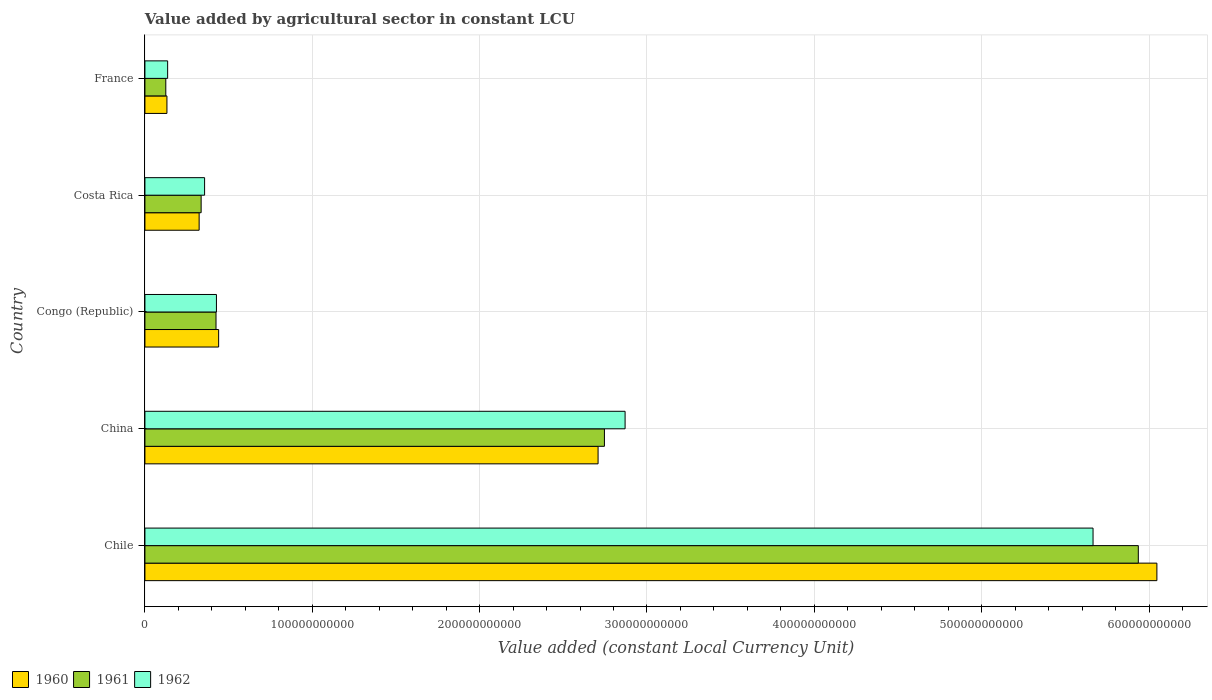How many groups of bars are there?
Your answer should be compact. 5. Are the number of bars on each tick of the Y-axis equal?
Make the answer very short. Yes. How many bars are there on the 4th tick from the top?
Your answer should be compact. 3. How many bars are there on the 1st tick from the bottom?
Keep it short and to the point. 3. What is the value added by agricultural sector in 1962 in France?
Ensure brevity in your answer.  1.36e+1. Across all countries, what is the maximum value added by agricultural sector in 1961?
Your answer should be compact. 5.94e+11. Across all countries, what is the minimum value added by agricultural sector in 1961?
Your answer should be very brief. 1.25e+1. In which country was the value added by agricultural sector in 1961 maximum?
Give a very brief answer. Chile. In which country was the value added by agricultural sector in 1962 minimum?
Give a very brief answer. France. What is the total value added by agricultural sector in 1960 in the graph?
Ensure brevity in your answer.  9.65e+11. What is the difference between the value added by agricultural sector in 1960 in Costa Rica and that in France?
Provide a short and direct response. 1.92e+1. What is the difference between the value added by agricultural sector in 1962 in Chile and the value added by agricultural sector in 1961 in France?
Provide a short and direct response. 5.54e+11. What is the average value added by agricultural sector in 1961 per country?
Provide a short and direct response. 1.91e+11. What is the difference between the value added by agricultural sector in 1961 and value added by agricultural sector in 1962 in Chile?
Make the answer very short. 2.70e+1. What is the ratio of the value added by agricultural sector in 1962 in China to that in Costa Rica?
Ensure brevity in your answer.  8.05. Is the difference between the value added by agricultural sector in 1961 in Chile and Congo (Republic) greater than the difference between the value added by agricultural sector in 1962 in Chile and Congo (Republic)?
Provide a succinct answer. Yes. What is the difference between the highest and the second highest value added by agricultural sector in 1960?
Your response must be concise. 3.34e+11. What is the difference between the highest and the lowest value added by agricultural sector in 1961?
Offer a terse response. 5.81e+11. In how many countries, is the value added by agricultural sector in 1960 greater than the average value added by agricultural sector in 1960 taken over all countries?
Offer a terse response. 2. What does the 1st bar from the top in Congo (Republic) represents?
Offer a very short reply. 1962. What does the 2nd bar from the bottom in China represents?
Your answer should be very brief. 1961. How many bars are there?
Give a very brief answer. 15. How many countries are there in the graph?
Keep it short and to the point. 5. What is the difference between two consecutive major ticks on the X-axis?
Your answer should be very brief. 1.00e+11. Does the graph contain any zero values?
Provide a short and direct response. No. How are the legend labels stacked?
Keep it short and to the point. Horizontal. What is the title of the graph?
Your answer should be compact. Value added by agricultural sector in constant LCU. Does "2005" appear as one of the legend labels in the graph?
Keep it short and to the point. No. What is the label or title of the X-axis?
Provide a short and direct response. Value added (constant Local Currency Unit). What is the Value added (constant Local Currency Unit) in 1960 in Chile?
Provide a short and direct response. 6.05e+11. What is the Value added (constant Local Currency Unit) in 1961 in Chile?
Ensure brevity in your answer.  5.94e+11. What is the Value added (constant Local Currency Unit) of 1962 in Chile?
Your answer should be very brief. 5.67e+11. What is the Value added (constant Local Currency Unit) of 1960 in China?
Provide a short and direct response. 2.71e+11. What is the Value added (constant Local Currency Unit) in 1961 in China?
Provide a short and direct response. 2.75e+11. What is the Value added (constant Local Currency Unit) of 1962 in China?
Make the answer very short. 2.87e+11. What is the Value added (constant Local Currency Unit) in 1960 in Congo (Republic)?
Keep it short and to the point. 4.41e+1. What is the Value added (constant Local Currency Unit) in 1961 in Congo (Republic)?
Provide a short and direct response. 4.25e+1. What is the Value added (constant Local Currency Unit) of 1962 in Congo (Republic)?
Make the answer very short. 4.27e+1. What is the Value added (constant Local Currency Unit) of 1960 in Costa Rica?
Your answer should be compact. 3.24e+1. What is the Value added (constant Local Currency Unit) in 1961 in Costa Rica?
Ensure brevity in your answer.  3.36e+1. What is the Value added (constant Local Currency Unit) in 1962 in Costa Rica?
Offer a very short reply. 3.57e+1. What is the Value added (constant Local Currency Unit) in 1960 in France?
Offer a very short reply. 1.32e+1. What is the Value added (constant Local Currency Unit) in 1961 in France?
Ensure brevity in your answer.  1.25e+1. What is the Value added (constant Local Currency Unit) in 1962 in France?
Give a very brief answer. 1.36e+1. Across all countries, what is the maximum Value added (constant Local Currency Unit) of 1960?
Offer a terse response. 6.05e+11. Across all countries, what is the maximum Value added (constant Local Currency Unit) of 1961?
Keep it short and to the point. 5.94e+11. Across all countries, what is the maximum Value added (constant Local Currency Unit) in 1962?
Offer a very short reply. 5.67e+11. Across all countries, what is the minimum Value added (constant Local Currency Unit) in 1960?
Give a very brief answer. 1.32e+1. Across all countries, what is the minimum Value added (constant Local Currency Unit) in 1961?
Offer a very short reply. 1.25e+1. Across all countries, what is the minimum Value added (constant Local Currency Unit) in 1962?
Your answer should be compact. 1.36e+1. What is the total Value added (constant Local Currency Unit) of 1960 in the graph?
Ensure brevity in your answer.  9.65e+11. What is the total Value added (constant Local Currency Unit) of 1961 in the graph?
Keep it short and to the point. 9.57e+11. What is the total Value added (constant Local Currency Unit) of 1962 in the graph?
Your answer should be compact. 9.45e+11. What is the difference between the Value added (constant Local Currency Unit) in 1960 in Chile and that in China?
Make the answer very short. 3.34e+11. What is the difference between the Value added (constant Local Currency Unit) in 1961 in Chile and that in China?
Offer a very short reply. 3.19e+11. What is the difference between the Value added (constant Local Currency Unit) in 1962 in Chile and that in China?
Make the answer very short. 2.80e+11. What is the difference between the Value added (constant Local Currency Unit) in 1960 in Chile and that in Congo (Republic)?
Ensure brevity in your answer.  5.61e+11. What is the difference between the Value added (constant Local Currency Unit) of 1961 in Chile and that in Congo (Republic)?
Make the answer very short. 5.51e+11. What is the difference between the Value added (constant Local Currency Unit) of 1962 in Chile and that in Congo (Republic)?
Keep it short and to the point. 5.24e+11. What is the difference between the Value added (constant Local Currency Unit) of 1960 in Chile and that in Costa Rica?
Make the answer very short. 5.72e+11. What is the difference between the Value added (constant Local Currency Unit) in 1961 in Chile and that in Costa Rica?
Provide a succinct answer. 5.60e+11. What is the difference between the Value added (constant Local Currency Unit) in 1962 in Chile and that in Costa Rica?
Ensure brevity in your answer.  5.31e+11. What is the difference between the Value added (constant Local Currency Unit) in 1960 in Chile and that in France?
Your answer should be very brief. 5.92e+11. What is the difference between the Value added (constant Local Currency Unit) of 1961 in Chile and that in France?
Ensure brevity in your answer.  5.81e+11. What is the difference between the Value added (constant Local Currency Unit) in 1962 in Chile and that in France?
Offer a terse response. 5.53e+11. What is the difference between the Value added (constant Local Currency Unit) in 1960 in China and that in Congo (Republic)?
Provide a short and direct response. 2.27e+11. What is the difference between the Value added (constant Local Currency Unit) of 1961 in China and that in Congo (Republic)?
Your answer should be very brief. 2.32e+11. What is the difference between the Value added (constant Local Currency Unit) of 1962 in China and that in Congo (Republic)?
Offer a terse response. 2.44e+11. What is the difference between the Value added (constant Local Currency Unit) in 1960 in China and that in Costa Rica?
Your response must be concise. 2.38e+11. What is the difference between the Value added (constant Local Currency Unit) of 1961 in China and that in Costa Rica?
Give a very brief answer. 2.41e+11. What is the difference between the Value added (constant Local Currency Unit) in 1962 in China and that in Costa Rica?
Your response must be concise. 2.51e+11. What is the difference between the Value added (constant Local Currency Unit) in 1960 in China and that in France?
Provide a short and direct response. 2.58e+11. What is the difference between the Value added (constant Local Currency Unit) in 1961 in China and that in France?
Keep it short and to the point. 2.62e+11. What is the difference between the Value added (constant Local Currency Unit) of 1962 in China and that in France?
Ensure brevity in your answer.  2.73e+11. What is the difference between the Value added (constant Local Currency Unit) in 1960 in Congo (Republic) and that in Costa Rica?
Make the answer very short. 1.17e+1. What is the difference between the Value added (constant Local Currency Unit) of 1961 in Congo (Republic) and that in Costa Rica?
Offer a very short reply. 8.89e+09. What is the difference between the Value added (constant Local Currency Unit) of 1962 in Congo (Republic) and that in Costa Rica?
Your answer should be compact. 7.08e+09. What is the difference between the Value added (constant Local Currency Unit) of 1960 in Congo (Republic) and that in France?
Keep it short and to the point. 3.09e+1. What is the difference between the Value added (constant Local Currency Unit) in 1961 in Congo (Republic) and that in France?
Offer a very short reply. 3.00e+1. What is the difference between the Value added (constant Local Currency Unit) of 1962 in Congo (Republic) and that in France?
Keep it short and to the point. 2.92e+1. What is the difference between the Value added (constant Local Currency Unit) in 1960 in Costa Rica and that in France?
Offer a terse response. 1.92e+1. What is the difference between the Value added (constant Local Currency Unit) of 1961 in Costa Rica and that in France?
Provide a short and direct response. 2.11e+1. What is the difference between the Value added (constant Local Currency Unit) in 1962 in Costa Rica and that in France?
Ensure brevity in your answer.  2.21e+1. What is the difference between the Value added (constant Local Currency Unit) in 1960 in Chile and the Value added (constant Local Currency Unit) in 1961 in China?
Offer a very short reply. 3.30e+11. What is the difference between the Value added (constant Local Currency Unit) in 1960 in Chile and the Value added (constant Local Currency Unit) in 1962 in China?
Your answer should be compact. 3.18e+11. What is the difference between the Value added (constant Local Currency Unit) of 1961 in Chile and the Value added (constant Local Currency Unit) of 1962 in China?
Ensure brevity in your answer.  3.07e+11. What is the difference between the Value added (constant Local Currency Unit) in 1960 in Chile and the Value added (constant Local Currency Unit) in 1961 in Congo (Republic)?
Provide a short and direct response. 5.62e+11. What is the difference between the Value added (constant Local Currency Unit) of 1960 in Chile and the Value added (constant Local Currency Unit) of 1962 in Congo (Republic)?
Provide a succinct answer. 5.62e+11. What is the difference between the Value added (constant Local Currency Unit) in 1961 in Chile and the Value added (constant Local Currency Unit) in 1962 in Congo (Republic)?
Make the answer very short. 5.51e+11. What is the difference between the Value added (constant Local Currency Unit) of 1960 in Chile and the Value added (constant Local Currency Unit) of 1961 in Costa Rica?
Your response must be concise. 5.71e+11. What is the difference between the Value added (constant Local Currency Unit) of 1960 in Chile and the Value added (constant Local Currency Unit) of 1962 in Costa Rica?
Offer a terse response. 5.69e+11. What is the difference between the Value added (constant Local Currency Unit) in 1961 in Chile and the Value added (constant Local Currency Unit) in 1962 in Costa Rica?
Offer a terse response. 5.58e+11. What is the difference between the Value added (constant Local Currency Unit) of 1960 in Chile and the Value added (constant Local Currency Unit) of 1961 in France?
Give a very brief answer. 5.92e+11. What is the difference between the Value added (constant Local Currency Unit) in 1960 in Chile and the Value added (constant Local Currency Unit) in 1962 in France?
Offer a terse response. 5.91e+11. What is the difference between the Value added (constant Local Currency Unit) in 1961 in Chile and the Value added (constant Local Currency Unit) in 1962 in France?
Offer a very short reply. 5.80e+11. What is the difference between the Value added (constant Local Currency Unit) in 1960 in China and the Value added (constant Local Currency Unit) in 1961 in Congo (Republic)?
Your response must be concise. 2.28e+11. What is the difference between the Value added (constant Local Currency Unit) in 1960 in China and the Value added (constant Local Currency Unit) in 1962 in Congo (Republic)?
Offer a very short reply. 2.28e+11. What is the difference between the Value added (constant Local Currency Unit) of 1961 in China and the Value added (constant Local Currency Unit) of 1962 in Congo (Republic)?
Your response must be concise. 2.32e+11. What is the difference between the Value added (constant Local Currency Unit) in 1960 in China and the Value added (constant Local Currency Unit) in 1961 in Costa Rica?
Your answer should be very brief. 2.37e+11. What is the difference between the Value added (constant Local Currency Unit) of 1960 in China and the Value added (constant Local Currency Unit) of 1962 in Costa Rica?
Your answer should be very brief. 2.35e+11. What is the difference between the Value added (constant Local Currency Unit) of 1961 in China and the Value added (constant Local Currency Unit) of 1962 in Costa Rica?
Your answer should be compact. 2.39e+11. What is the difference between the Value added (constant Local Currency Unit) in 1960 in China and the Value added (constant Local Currency Unit) in 1961 in France?
Make the answer very short. 2.58e+11. What is the difference between the Value added (constant Local Currency Unit) of 1960 in China and the Value added (constant Local Currency Unit) of 1962 in France?
Give a very brief answer. 2.57e+11. What is the difference between the Value added (constant Local Currency Unit) of 1961 in China and the Value added (constant Local Currency Unit) of 1962 in France?
Your answer should be compact. 2.61e+11. What is the difference between the Value added (constant Local Currency Unit) in 1960 in Congo (Republic) and the Value added (constant Local Currency Unit) in 1961 in Costa Rica?
Provide a short and direct response. 1.05e+1. What is the difference between the Value added (constant Local Currency Unit) in 1960 in Congo (Republic) and the Value added (constant Local Currency Unit) in 1962 in Costa Rica?
Make the answer very short. 8.40e+09. What is the difference between the Value added (constant Local Currency Unit) of 1961 in Congo (Republic) and the Value added (constant Local Currency Unit) of 1962 in Costa Rica?
Your response must be concise. 6.83e+09. What is the difference between the Value added (constant Local Currency Unit) of 1960 in Congo (Republic) and the Value added (constant Local Currency Unit) of 1961 in France?
Provide a succinct answer. 3.16e+1. What is the difference between the Value added (constant Local Currency Unit) of 1960 in Congo (Republic) and the Value added (constant Local Currency Unit) of 1962 in France?
Your answer should be compact. 3.05e+1. What is the difference between the Value added (constant Local Currency Unit) in 1961 in Congo (Republic) and the Value added (constant Local Currency Unit) in 1962 in France?
Provide a short and direct response. 2.89e+1. What is the difference between the Value added (constant Local Currency Unit) of 1960 in Costa Rica and the Value added (constant Local Currency Unit) of 1961 in France?
Ensure brevity in your answer.  1.99e+1. What is the difference between the Value added (constant Local Currency Unit) of 1960 in Costa Rica and the Value added (constant Local Currency Unit) of 1962 in France?
Offer a very short reply. 1.88e+1. What is the difference between the Value added (constant Local Currency Unit) of 1961 in Costa Rica and the Value added (constant Local Currency Unit) of 1962 in France?
Your answer should be compact. 2.00e+1. What is the average Value added (constant Local Currency Unit) of 1960 per country?
Give a very brief answer. 1.93e+11. What is the average Value added (constant Local Currency Unit) in 1961 per country?
Ensure brevity in your answer.  1.91e+11. What is the average Value added (constant Local Currency Unit) in 1962 per country?
Provide a succinct answer. 1.89e+11. What is the difference between the Value added (constant Local Currency Unit) of 1960 and Value added (constant Local Currency Unit) of 1961 in Chile?
Offer a terse response. 1.11e+1. What is the difference between the Value added (constant Local Currency Unit) in 1960 and Value added (constant Local Currency Unit) in 1962 in Chile?
Your response must be concise. 3.82e+1. What is the difference between the Value added (constant Local Currency Unit) of 1961 and Value added (constant Local Currency Unit) of 1962 in Chile?
Your answer should be very brief. 2.70e+1. What is the difference between the Value added (constant Local Currency Unit) in 1960 and Value added (constant Local Currency Unit) in 1961 in China?
Offer a terse response. -3.79e+09. What is the difference between the Value added (constant Local Currency Unit) of 1960 and Value added (constant Local Currency Unit) of 1962 in China?
Your answer should be very brief. -1.61e+1. What is the difference between the Value added (constant Local Currency Unit) in 1961 and Value added (constant Local Currency Unit) in 1962 in China?
Ensure brevity in your answer.  -1.24e+1. What is the difference between the Value added (constant Local Currency Unit) of 1960 and Value added (constant Local Currency Unit) of 1961 in Congo (Republic)?
Your answer should be very brief. 1.57e+09. What is the difference between the Value added (constant Local Currency Unit) of 1960 and Value added (constant Local Currency Unit) of 1962 in Congo (Republic)?
Give a very brief answer. 1.32e+09. What is the difference between the Value added (constant Local Currency Unit) of 1961 and Value added (constant Local Currency Unit) of 1962 in Congo (Republic)?
Your response must be concise. -2.56e+08. What is the difference between the Value added (constant Local Currency Unit) in 1960 and Value added (constant Local Currency Unit) in 1961 in Costa Rica?
Your answer should be very brief. -1.19e+09. What is the difference between the Value added (constant Local Currency Unit) in 1960 and Value added (constant Local Currency Unit) in 1962 in Costa Rica?
Offer a terse response. -3.25e+09. What is the difference between the Value added (constant Local Currency Unit) in 1961 and Value added (constant Local Currency Unit) in 1962 in Costa Rica?
Offer a very short reply. -2.06e+09. What is the difference between the Value added (constant Local Currency Unit) of 1960 and Value added (constant Local Currency Unit) of 1961 in France?
Provide a succinct answer. 6.84e+08. What is the difference between the Value added (constant Local Currency Unit) in 1960 and Value added (constant Local Currency Unit) in 1962 in France?
Your response must be concise. -4.23e+08. What is the difference between the Value added (constant Local Currency Unit) of 1961 and Value added (constant Local Currency Unit) of 1962 in France?
Give a very brief answer. -1.11e+09. What is the ratio of the Value added (constant Local Currency Unit) in 1960 in Chile to that in China?
Provide a succinct answer. 2.23. What is the ratio of the Value added (constant Local Currency Unit) of 1961 in Chile to that in China?
Your answer should be very brief. 2.16. What is the ratio of the Value added (constant Local Currency Unit) in 1962 in Chile to that in China?
Provide a succinct answer. 1.97. What is the ratio of the Value added (constant Local Currency Unit) in 1960 in Chile to that in Congo (Republic)?
Keep it short and to the point. 13.73. What is the ratio of the Value added (constant Local Currency Unit) of 1961 in Chile to that in Congo (Republic)?
Keep it short and to the point. 13.97. What is the ratio of the Value added (constant Local Currency Unit) of 1962 in Chile to that in Congo (Republic)?
Your answer should be very brief. 13.26. What is the ratio of the Value added (constant Local Currency Unit) in 1960 in Chile to that in Costa Rica?
Ensure brevity in your answer.  18.66. What is the ratio of the Value added (constant Local Currency Unit) in 1961 in Chile to that in Costa Rica?
Make the answer very short. 17.67. What is the ratio of the Value added (constant Local Currency Unit) of 1962 in Chile to that in Costa Rica?
Your answer should be compact. 15.89. What is the ratio of the Value added (constant Local Currency Unit) of 1960 in Chile to that in France?
Offer a very short reply. 45.96. What is the ratio of the Value added (constant Local Currency Unit) of 1961 in Chile to that in France?
Your answer should be very brief. 47.59. What is the ratio of the Value added (constant Local Currency Unit) in 1962 in Chile to that in France?
Your answer should be very brief. 41.72. What is the ratio of the Value added (constant Local Currency Unit) of 1960 in China to that in Congo (Republic)?
Your response must be concise. 6.15. What is the ratio of the Value added (constant Local Currency Unit) in 1961 in China to that in Congo (Republic)?
Your answer should be very brief. 6.46. What is the ratio of the Value added (constant Local Currency Unit) in 1962 in China to that in Congo (Republic)?
Ensure brevity in your answer.  6.71. What is the ratio of the Value added (constant Local Currency Unit) of 1960 in China to that in Costa Rica?
Offer a very short reply. 8.36. What is the ratio of the Value added (constant Local Currency Unit) of 1961 in China to that in Costa Rica?
Make the answer very short. 8.17. What is the ratio of the Value added (constant Local Currency Unit) of 1962 in China to that in Costa Rica?
Offer a terse response. 8.05. What is the ratio of the Value added (constant Local Currency Unit) in 1960 in China to that in France?
Give a very brief answer. 20.58. What is the ratio of the Value added (constant Local Currency Unit) in 1961 in China to that in France?
Provide a succinct answer. 22.01. What is the ratio of the Value added (constant Local Currency Unit) of 1962 in China to that in France?
Provide a succinct answer. 21.13. What is the ratio of the Value added (constant Local Currency Unit) in 1960 in Congo (Republic) to that in Costa Rica?
Offer a very short reply. 1.36. What is the ratio of the Value added (constant Local Currency Unit) in 1961 in Congo (Republic) to that in Costa Rica?
Provide a short and direct response. 1.26. What is the ratio of the Value added (constant Local Currency Unit) of 1962 in Congo (Republic) to that in Costa Rica?
Provide a succinct answer. 1.2. What is the ratio of the Value added (constant Local Currency Unit) of 1960 in Congo (Republic) to that in France?
Your response must be concise. 3.35. What is the ratio of the Value added (constant Local Currency Unit) in 1961 in Congo (Republic) to that in France?
Ensure brevity in your answer.  3.41. What is the ratio of the Value added (constant Local Currency Unit) in 1962 in Congo (Republic) to that in France?
Your answer should be very brief. 3.15. What is the ratio of the Value added (constant Local Currency Unit) of 1960 in Costa Rica to that in France?
Your answer should be compact. 2.46. What is the ratio of the Value added (constant Local Currency Unit) in 1961 in Costa Rica to that in France?
Make the answer very short. 2.69. What is the ratio of the Value added (constant Local Currency Unit) of 1962 in Costa Rica to that in France?
Ensure brevity in your answer.  2.63. What is the difference between the highest and the second highest Value added (constant Local Currency Unit) in 1960?
Offer a terse response. 3.34e+11. What is the difference between the highest and the second highest Value added (constant Local Currency Unit) in 1961?
Offer a terse response. 3.19e+11. What is the difference between the highest and the second highest Value added (constant Local Currency Unit) in 1962?
Your response must be concise. 2.80e+11. What is the difference between the highest and the lowest Value added (constant Local Currency Unit) of 1960?
Offer a very short reply. 5.92e+11. What is the difference between the highest and the lowest Value added (constant Local Currency Unit) of 1961?
Provide a succinct answer. 5.81e+11. What is the difference between the highest and the lowest Value added (constant Local Currency Unit) in 1962?
Your answer should be very brief. 5.53e+11. 